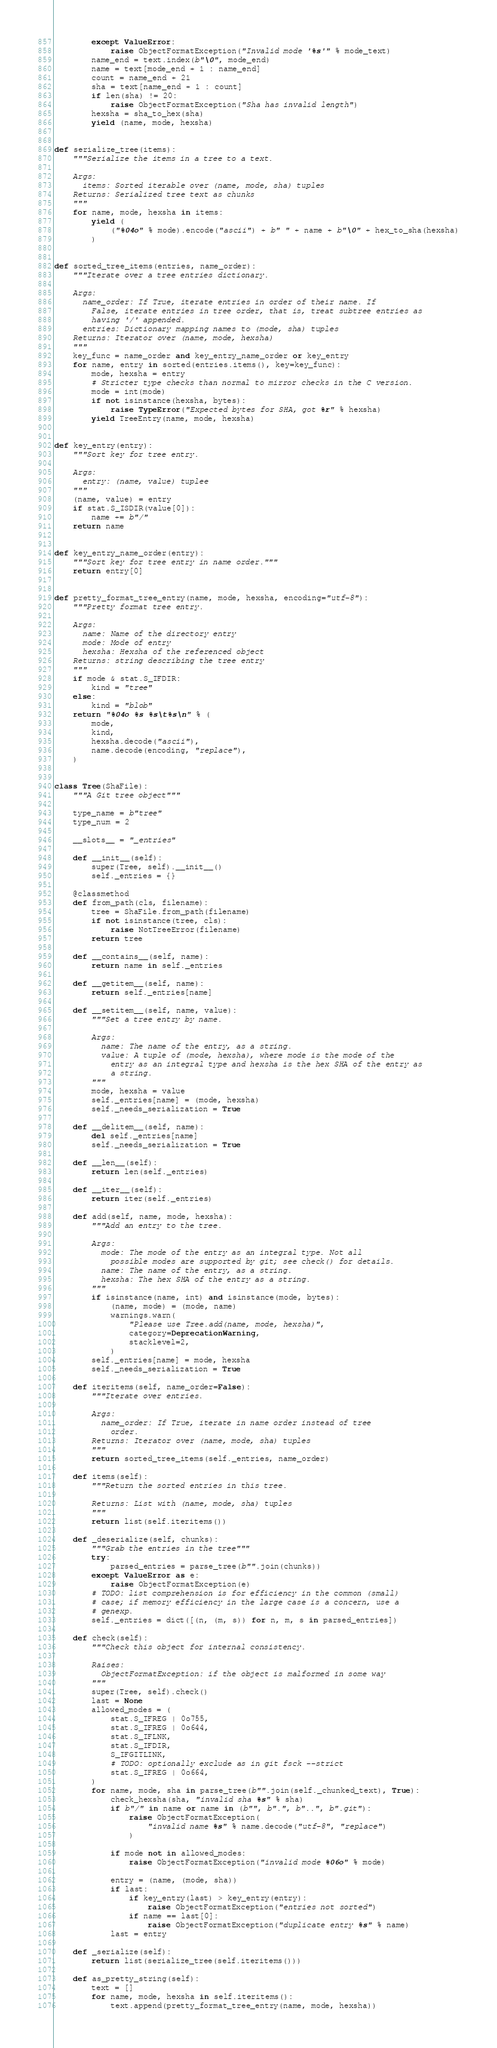<code> <loc_0><loc_0><loc_500><loc_500><_Python_>        except ValueError:
            raise ObjectFormatException("Invalid mode '%s'" % mode_text)
        name_end = text.index(b"\0", mode_end)
        name = text[mode_end + 1 : name_end]
        count = name_end + 21
        sha = text[name_end + 1 : count]
        if len(sha) != 20:
            raise ObjectFormatException("Sha has invalid length")
        hexsha = sha_to_hex(sha)
        yield (name, mode, hexsha)


def serialize_tree(items):
    """Serialize the items in a tree to a text.

    Args:
      items: Sorted iterable over (name, mode, sha) tuples
    Returns: Serialized tree text as chunks
    """
    for name, mode, hexsha in items:
        yield (
            ("%04o" % mode).encode("ascii") + b" " + name + b"\0" + hex_to_sha(hexsha)
        )


def sorted_tree_items(entries, name_order):
    """Iterate over a tree entries dictionary.

    Args:
      name_order: If True, iterate entries in order of their name. If
        False, iterate entries in tree order, that is, treat subtree entries as
        having '/' appended.
      entries: Dictionary mapping names to (mode, sha) tuples
    Returns: Iterator over (name, mode, hexsha)
    """
    key_func = name_order and key_entry_name_order or key_entry
    for name, entry in sorted(entries.items(), key=key_func):
        mode, hexsha = entry
        # Stricter type checks than normal to mirror checks in the C version.
        mode = int(mode)
        if not isinstance(hexsha, bytes):
            raise TypeError("Expected bytes for SHA, got %r" % hexsha)
        yield TreeEntry(name, mode, hexsha)


def key_entry(entry):
    """Sort key for tree entry.

    Args:
      entry: (name, value) tuplee
    """
    (name, value) = entry
    if stat.S_ISDIR(value[0]):
        name += b"/"
    return name


def key_entry_name_order(entry):
    """Sort key for tree entry in name order."""
    return entry[0]


def pretty_format_tree_entry(name, mode, hexsha, encoding="utf-8"):
    """Pretty format tree entry.

    Args:
      name: Name of the directory entry
      mode: Mode of entry
      hexsha: Hexsha of the referenced object
    Returns: string describing the tree entry
    """
    if mode & stat.S_IFDIR:
        kind = "tree"
    else:
        kind = "blob"
    return "%04o %s %s\t%s\n" % (
        mode,
        kind,
        hexsha.decode("ascii"),
        name.decode(encoding, "replace"),
    )


class Tree(ShaFile):
    """A Git tree object"""

    type_name = b"tree"
    type_num = 2

    __slots__ = "_entries"

    def __init__(self):
        super(Tree, self).__init__()
        self._entries = {}

    @classmethod
    def from_path(cls, filename):
        tree = ShaFile.from_path(filename)
        if not isinstance(tree, cls):
            raise NotTreeError(filename)
        return tree

    def __contains__(self, name):
        return name in self._entries

    def __getitem__(self, name):
        return self._entries[name]

    def __setitem__(self, name, value):
        """Set a tree entry by name.

        Args:
          name: The name of the entry, as a string.
          value: A tuple of (mode, hexsha), where mode is the mode of the
            entry as an integral type and hexsha is the hex SHA of the entry as
            a string.
        """
        mode, hexsha = value
        self._entries[name] = (mode, hexsha)
        self._needs_serialization = True

    def __delitem__(self, name):
        del self._entries[name]
        self._needs_serialization = True

    def __len__(self):
        return len(self._entries)

    def __iter__(self):
        return iter(self._entries)

    def add(self, name, mode, hexsha):
        """Add an entry to the tree.

        Args:
          mode: The mode of the entry as an integral type. Not all
            possible modes are supported by git; see check() for details.
          name: The name of the entry, as a string.
          hexsha: The hex SHA of the entry as a string.
        """
        if isinstance(name, int) and isinstance(mode, bytes):
            (name, mode) = (mode, name)
            warnings.warn(
                "Please use Tree.add(name, mode, hexsha)",
                category=DeprecationWarning,
                stacklevel=2,
            )
        self._entries[name] = mode, hexsha
        self._needs_serialization = True

    def iteritems(self, name_order=False):
        """Iterate over entries.

        Args:
          name_order: If True, iterate in name order instead of tree
            order.
        Returns: Iterator over (name, mode, sha) tuples
        """
        return sorted_tree_items(self._entries, name_order)

    def items(self):
        """Return the sorted entries in this tree.

        Returns: List with (name, mode, sha) tuples
        """
        return list(self.iteritems())

    def _deserialize(self, chunks):
        """Grab the entries in the tree"""
        try:
            parsed_entries = parse_tree(b"".join(chunks))
        except ValueError as e:
            raise ObjectFormatException(e)
        # TODO: list comprehension is for efficiency in the common (small)
        # case; if memory efficiency in the large case is a concern, use a
        # genexp.
        self._entries = dict([(n, (m, s)) for n, m, s in parsed_entries])

    def check(self):
        """Check this object for internal consistency.

        Raises:
          ObjectFormatException: if the object is malformed in some way
        """
        super(Tree, self).check()
        last = None
        allowed_modes = (
            stat.S_IFREG | 0o755,
            stat.S_IFREG | 0o644,
            stat.S_IFLNK,
            stat.S_IFDIR,
            S_IFGITLINK,
            # TODO: optionally exclude as in git fsck --strict
            stat.S_IFREG | 0o664,
        )
        for name, mode, sha in parse_tree(b"".join(self._chunked_text), True):
            check_hexsha(sha, "invalid sha %s" % sha)
            if b"/" in name or name in (b"", b".", b"..", b".git"):
                raise ObjectFormatException(
                    "invalid name %s" % name.decode("utf-8", "replace")
                )

            if mode not in allowed_modes:
                raise ObjectFormatException("invalid mode %06o" % mode)

            entry = (name, (mode, sha))
            if last:
                if key_entry(last) > key_entry(entry):
                    raise ObjectFormatException("entries not sorted")
                if name == last[0]:
                    raise ObjectFormatException("duplicate entry %s" % name)
            last = entry

    def _serialize(self):
        return list(serialize_tree(self.iteritems()))

    def as_pretty_string(self):
        text = []
        for name, mode, hexsha in self.iteritems():
            text.append(pretty_format_tree_entry(name, mode, hexsha))</code> 